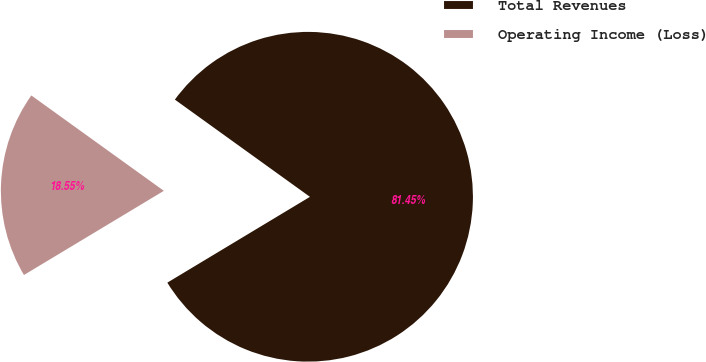<chart> <loc_0><loc_0><loc_500><loc_500><pie_chart><fcel>Total Revenues<fcel>Operating Income (Loss)<nl><fcel>81.45%<fcel>18.55%<nl></chart> 